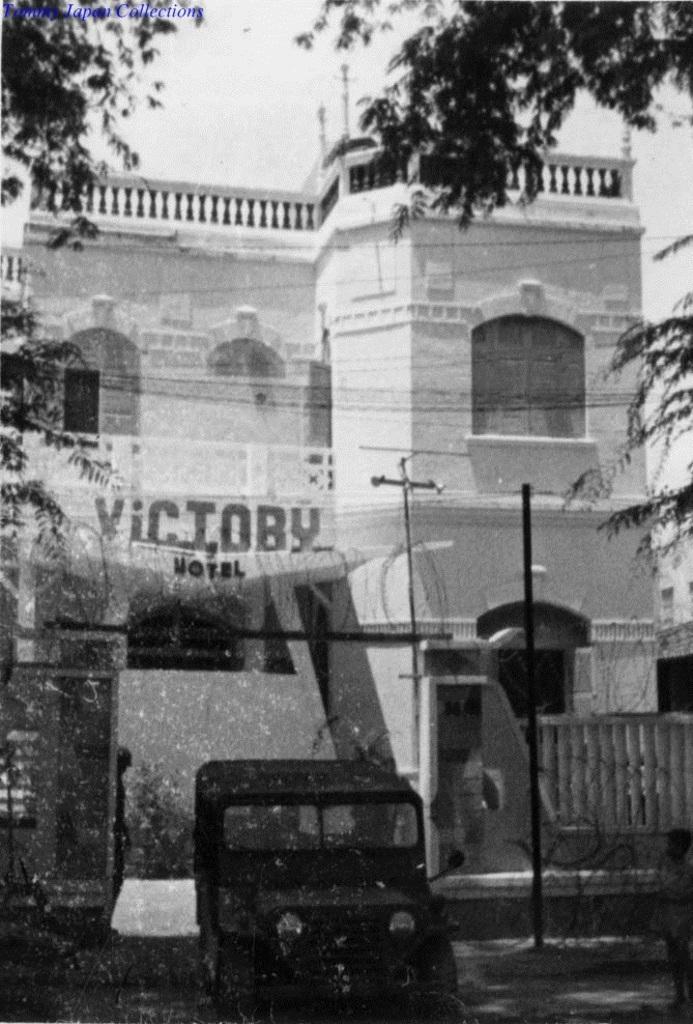Please provide a concise description of this image. In this image in the center there is one building, and in the foreground there is one vehicle on the right side there is one pole and trees. And on the left side there is one gate and one person is standing, at the bottom there is a road. On the top of the image there is sky. 